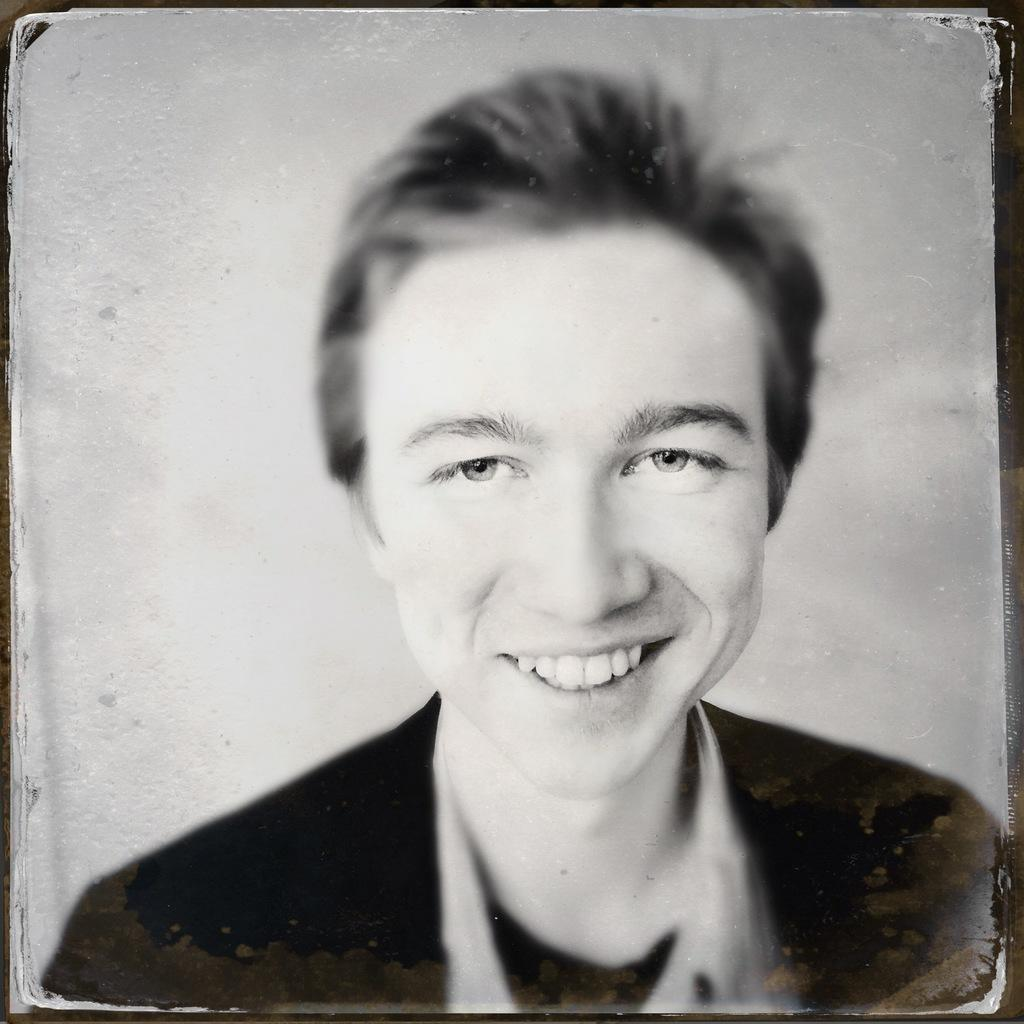What is the color scheme of the image? The image is black and white. Who is present in the image? There is a man in the image. What is the man wearing? The man is wearing a black blazer. What is the man's facial expression? The man is smiling. What is the background of the image? The background of the image is white. What might the image be used for? The image might be a photo frame. What type of coal is being used to play the guitar in the image? There is no coal or guitar present in the image; it features a man wearing a black blazer and smiling. How many people are attending the mass in the image? There is no mass or people attending a mass present in the image; it features a man wearing a black blazer and smiling. 